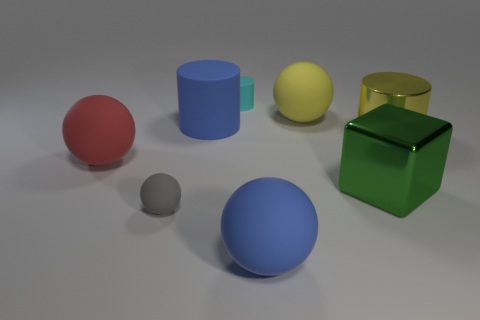Is the number of small cyan matte cylinders to the right of the blue cylinder greater than the number of yellow rubber objects?
Offer a terse response. No. There is a small gray thing in front of the big cylinder behind the yellow metallic cylinder to the right of the yellow rubber ball; what is it made of?
Ensure brevity in your answer.  Rubber. How many objects are either small metal balls or large things that are behind the large green shiny object?
Your answer should be compact. 4. Do the big ball that is right of the blue sphere and the small sphere have the same color?
Offer a terse response. No. Are there more blue rubber cylinders right of the tiny ball than large balls behind the large blue rubber cylinder?
Offer a very short reply. No. Are there any other things that are the same color as the metal cylinder?
Your answer should be very brief. Yes. What number of objects are either blue rubber cylinders or large purple matte blocks?
Offer a very short reply. 1. Does the blue matte thing in front of the red sphere have the same size as the yellow metal thing?
Your answer should be very brief. Yes. What number of other objects are the same size as the gray rubber object?
Offer a terse response. 1. Are there any large gray cylinders?
Your answer should be very brief. No. 